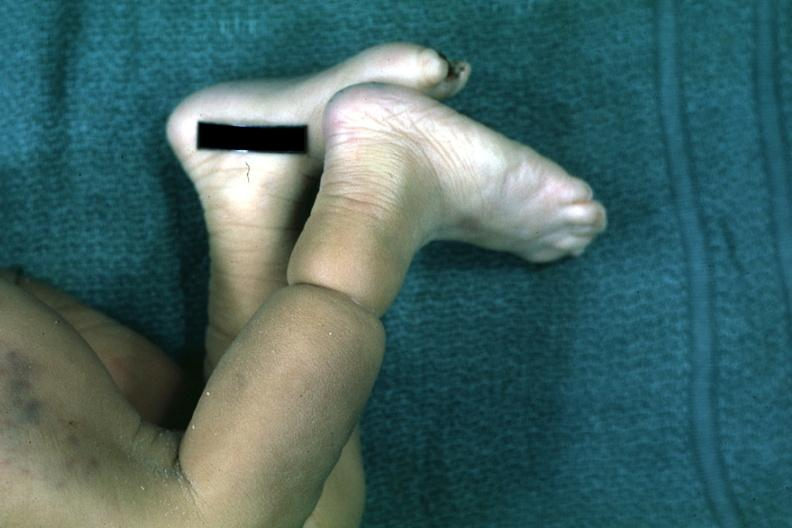s band constriction in skin above ankle of infant present?
Answer the question using a single word or phrase. Yes 